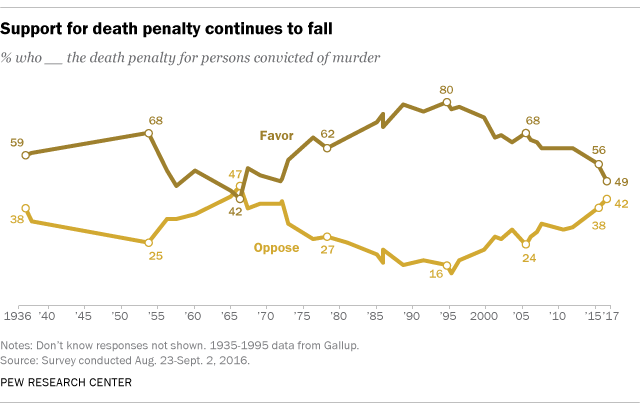Point out several critical features in this image. In 2017, 49% of people supported the use of the death penalty for individuals convicted of murder. The difference in value between those who favor and oppose the death penalty for persons convicted of murder in 2015 was 18%. 